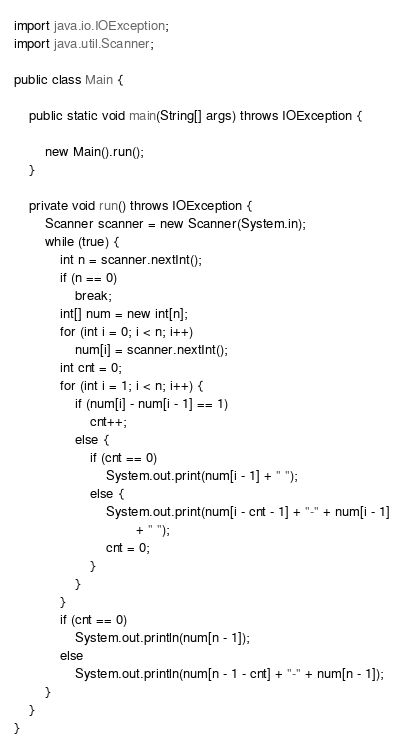<code> <loc_0><loc_0><loc_500><loc_500><_Java_>
import java.io.IOException;
import java.util.Scanner;

public class Main {

	public static void main(String[] args) throws IOException {

		new Main().run();
	}

	private void run() throws IOException {
		Scanner scanner = new Scanner(System.in);
		while (true) {
			int n = scanner.nextInt();
			if (n == 0)
				break;
			int[] num = new int[n];
			for (int i = 0; i < n; i++)
				num[i] = scanner.nextInt();
			int cnt = 0;
			for (int i = 1; i < n; i++) {
				if (num[i] - num[i - 1] == 1)
					cnt++;
				else {
					if (cnt == 0)
						System.out.print(num[i - 1] + " ");
					else {
						System.out.print(num[i - cnt - 1] + "-" + num[i - 1]
								+ " ");
						cnt = 0;
					}
				}
			}
			if (cnt == 0)
				System.out.println(num[n - 1]);
			else
				System.out.println(num[n - 1 - cnt] + "-" + num[n - 1]);
		}
	}
}</code> 